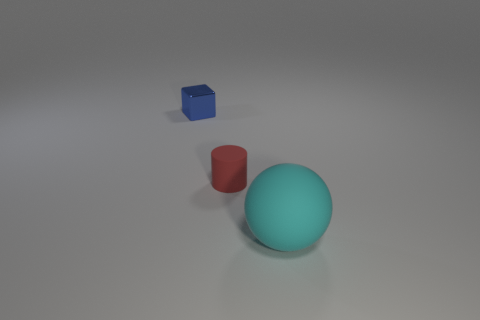Do the red cylinder and the object on the right side of the red rubber thing have the same size?
Offer a terse response. No. How many objects are either brown shiny objects or matte things?
Keep it short and to the point. 2. How many other things are there of the same size as the rubber cylinder?
Your answer should be very brief. 1. How many cubes are small red matte things or rubber objects?
Your answer should be compact. 0. What material is the tiny object behind the tiny object on the right side of the small cube?
Provide a short and direct response. Metal. Do the small red thing and the large thing that is in front of the cylinder have the same material?
Keep it short and to the point. Yes. What number of objects are objects that are to the right of the cylinder or red rubber things?
Offer a very short reply. 2. Does the red thing have the same shape as the rubber object right of the small matte thing?
Make the answer very short. No. What number of things are both behind the large cyan matte object and on the right side of the blue metal object?
Provide a succinct answer. 1. What size is the matte thing behind the thing in front of the small red cylinder?
Provide a succinct answer. Small. 